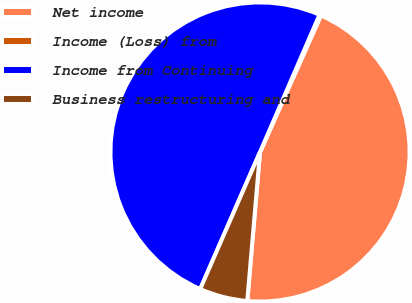Convert chart. <chart><loc_0><loc_0><loc_500><loc_500><pie_chart><fcel>Net income<fcel>Income (Loss) from<fcel>Income from Continuing<fcel>Business restructuring and<nl><fcel>44.68%<fcel>0.17%<fcel>49.96%<fcel>5.19%<nl></chart> 